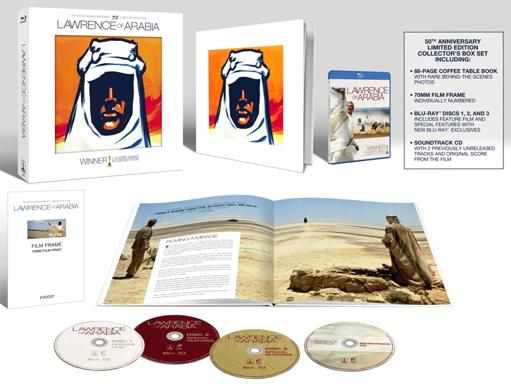What is the significance of the book included in the box set? The coffee table book included in the 'Lawrence of Arabia' box set offers a wealth of information, featuring rare behind-the-scenes photographs and articles detailing the film's production, the challenges encountered during its filming, and its impact on cinema. The book serves both as an art piece and an informative resource, providing deeper insights into the creation of this iconic film. 